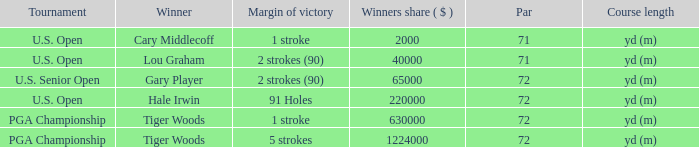When hale irwin is the winner what is the margin of victory? 91 Holes. 